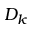Convert formula to latex. <formula><loc_0><loc_0><loc_500><loc_500>D _ { k }</formula> 